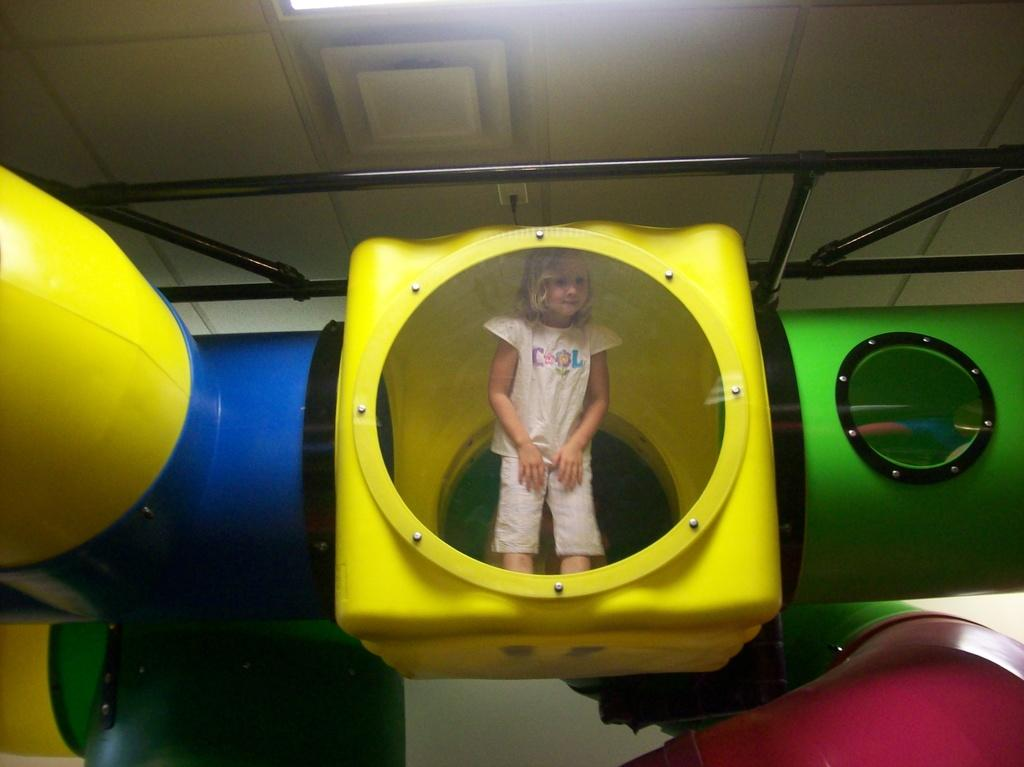What is the main subject of the image? There is a girl standing in the image. What objects can be seen in the image besides the girl? There are poles, rods, and other objects visible in the image. What can be seen in the background of the image? There is a ceiling and a light visible in the background of the image. What type of car can be seen in the image? There is no car present in the image. Can you tell me where the zoo is located in the image? There is no zoo present in the image. 